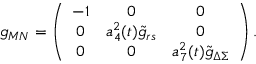<formula> <loc_0><loc_0><loc_500><loc_500>g _ { M N } = \left ( \begin{array} { c c c } { - 1 } & { 0 } & { 0 } \\ { 0 } & { { a _ { 4 } ^ { 2 } ( t ) { \tilde { g } } _ { r s } } } & { 0 } \\ { 0 } & { 0 } & { { a _ { 7 } ^ { 2 } ( t ) { \tilde { g } } _ { \Delta \Sigma } } } \end{array} \right ) .</formula> 